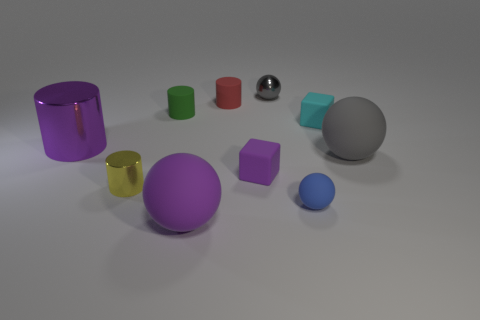What number of other things are there of the same color as the large shiny cylinder?
Your answer should be compact. 2. Is the gray shiny thing the same size as the gray rubber thing?
Make the answer very short. No. There is a metallic cylinder that is behind the gray object that is in front of the tiny green rubber thing; what color is it?
Make the answer very short. Purple. The small metal cylinder is what color?
Offer a very short reply. Yellow. Is there a big rubber object that has the same color as the small metal sphere?
Your response must be concise. Yes. Do the small block that is in front of the big purple metallic thing and the big metal cylinder have the same color?
Offer a terse response. Yes. How many objects are large balls to the left of the tiny purple object or large brown balls?
Your answer should be compact. 1. Are there any large spheres behind the tiny yellow cylinder?
Ensure brevity in your answer.  Yes. There is a large object that is the same color as the large cylinder; what material is it?
Keep it short and to the point. Rubber. Are the cube that is to the right of the small purple matte cube and the purple cube made of the same material?
Make the answer very short. Yes. 